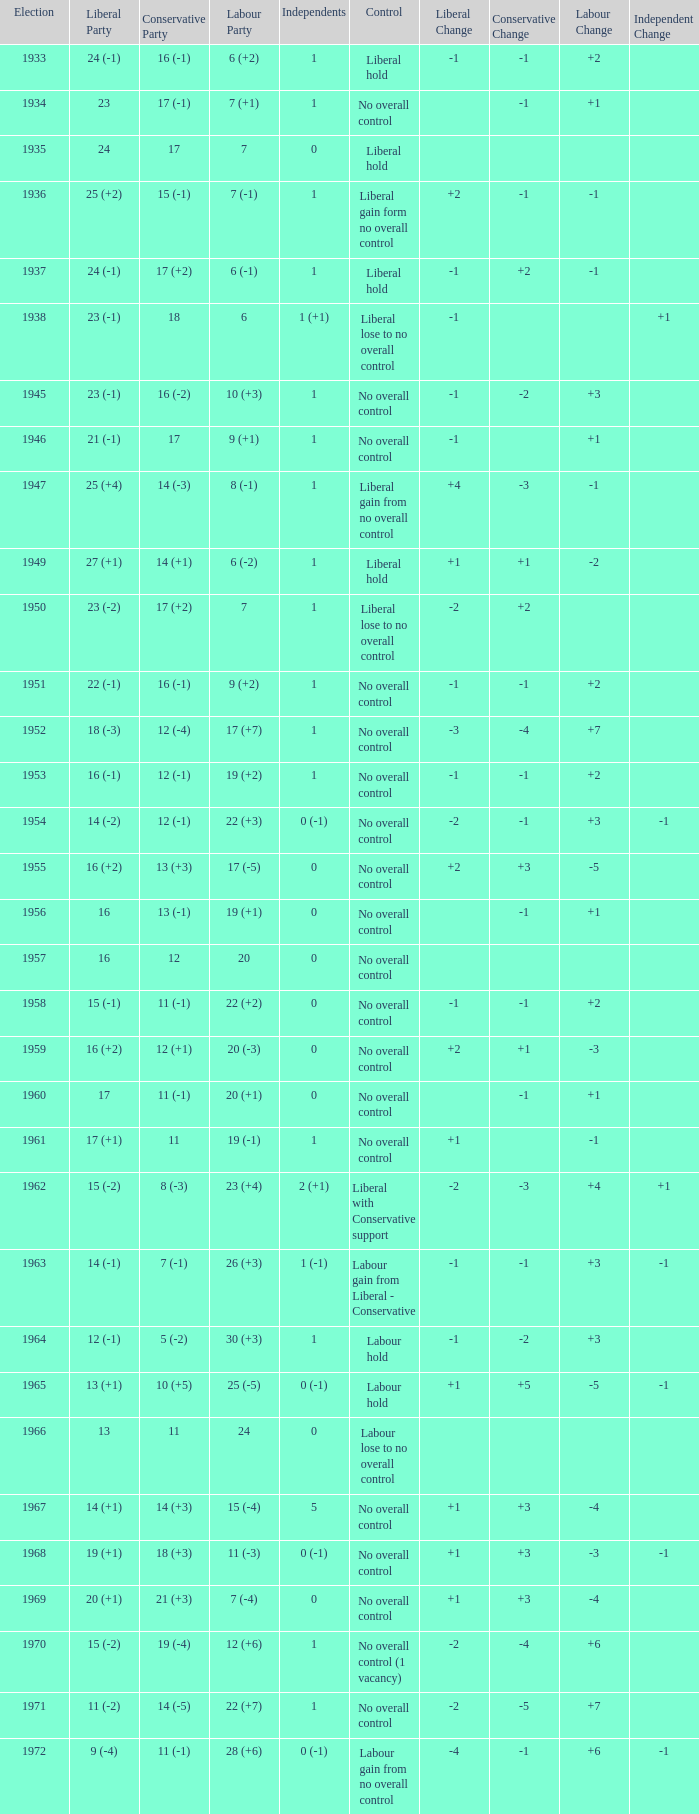Who was in control the year that Labour Party won 12 (+6) seats? No overall control (1 vacancy). 